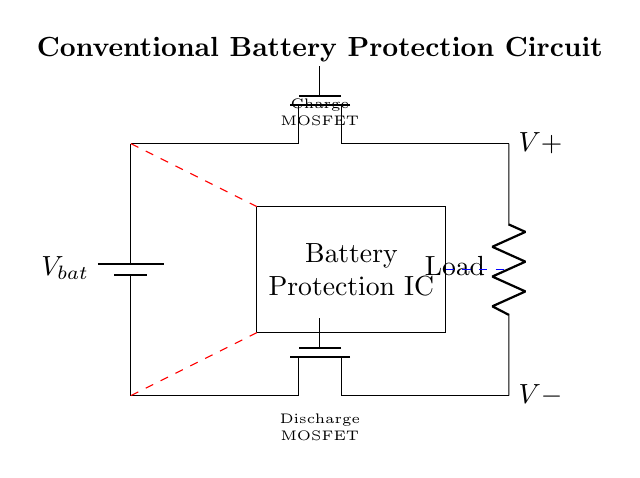What is the main function of the Battery Protection IC? The Battery Protection IC's main function is to monitor the battery's voltage and current to prevent overcharging and over-discharging, ensuring safe operation.
Answer: to prevent overcharging and over-discharging What type of MOSFET is used for charging? The circuit shows a Tnmos type MOSFET labeled as "charge" specifically used for managing the charging path of the battery.
Answer: Tnmos What component is connected to the load? The component connected to the load in this circuit is a resistor, which is designated as 'Load' in the diagram.
Answer: Resistor What do the dashed red lines represent? The dashed red lines illustrate voltage sense lines that are used for monitoring the battery voltage at both charging and discharging terminals, critical for the Battery Protection IC's operation.
Answer: Voltage sense lines How many MOSFETs are used in this circuit? There are two MOSFETs present in the circuit, one for charging and one for discharging, making a total of two.
Answer: Two How does the circuit prevent over-discharge? The circuit prevents over-discharge by utilizing the discharge MOSFET, controlled by the Battery Protection IC, which disconnects the load if the battery voltage drops below a certain threshold.
Answer: By disconnecting the load What is the voltage across the battery? The battery voltage (V_bat) is not specifically labeled with a numerical value in the diagram, but it is represented as a variable dependent on the battery state.
Answer: Variable (V_bat) 